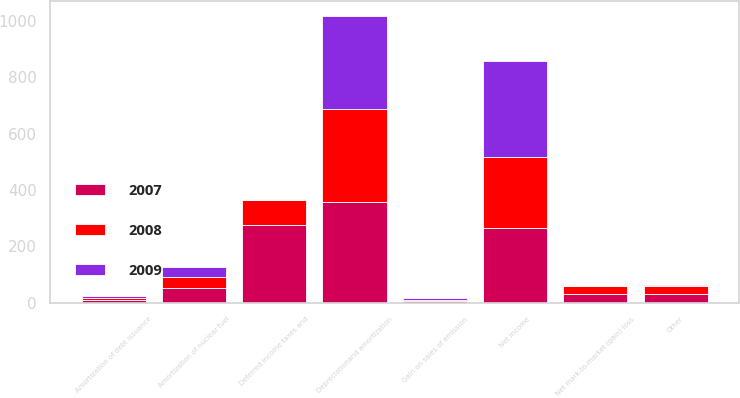Convert chart. <chart><loc_0><loc_0><loc_500><loc_500><stacked_bar_chart><ecel><fcel>Net income<fcel>Gain on sales of emission<fcel>Net mark-to-market (gain) loss<fcel>Depreciationand amortization<fcel>Amortization of nuclear fuel<fcel>Amortization of debt issuance<fcel>Deferred income taxes and<fcel>Other<nl><fcel>2007<fcel>265<fcel>5<fcel>29<fcel>357<fcel>53<fcel>10<fcel>276<fcel>30<nl><fcel>2008<fcel>251<fcel>5<fcel>29<fcel>329<fcel>37<fcel>6<fcel>89<fcel>28<nl><fcel>2009<fcel>342<fcel>5<fcel>2<fcel>333<fcel>37<fcel>6<fcel>1<fcel>6<nl></chart> 